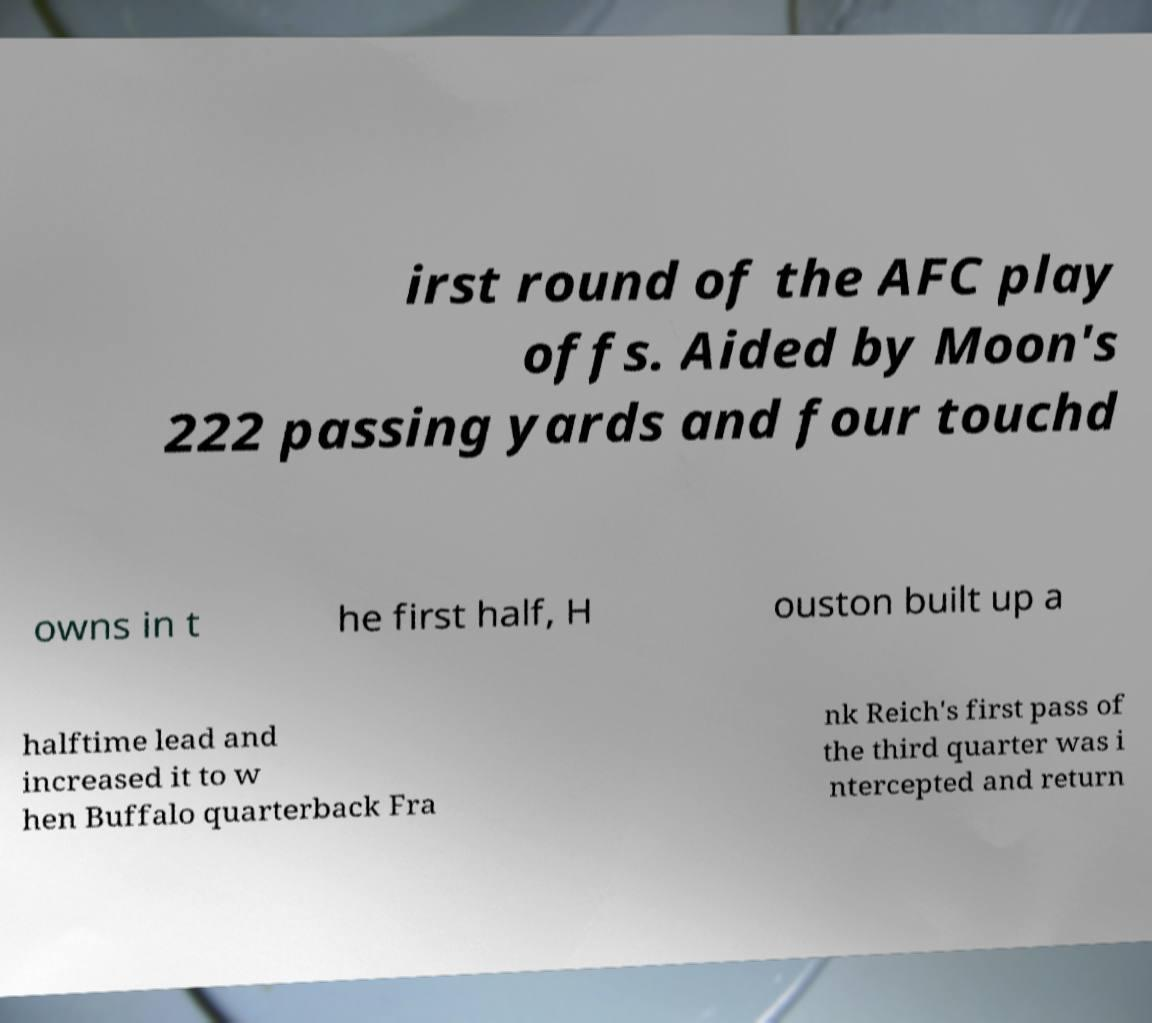Please identify and transcribe the text found in this image. irst round of the AFC play offs. Aided by Moon's 222 passing yards and four touchd owns in t he first half, H ouston built up a halftime lead and increased it to w hen Buffalo quarterback Fra nk Reich's first pass of the third quarter was i ntercepted and return 